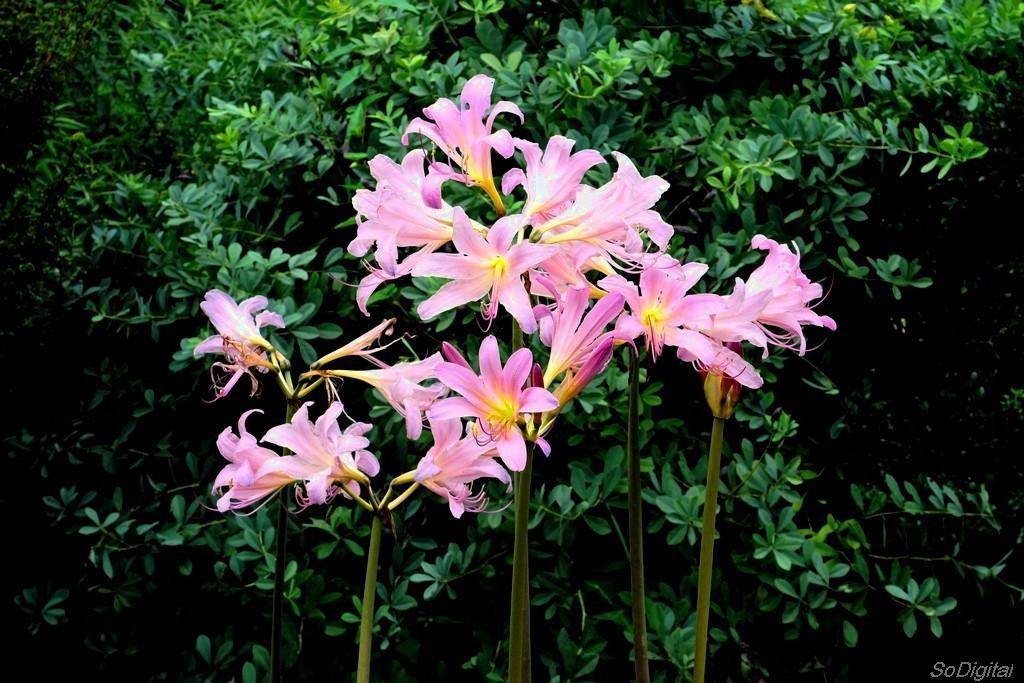Describe this image in one or two sentences. In this image there are leaves of a plant. In the foreground there are flowers to the stems. In the bottom right there is text on the image. 